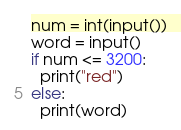Convert code to text. <code><loc_0><loc_0><loc_500><loc_500><_Python_>num = int(input())
word = input()
if num <= 3200:
  print("red")
else:
  print(word)</code> 